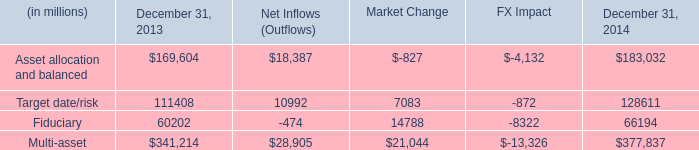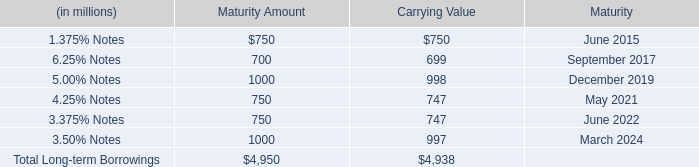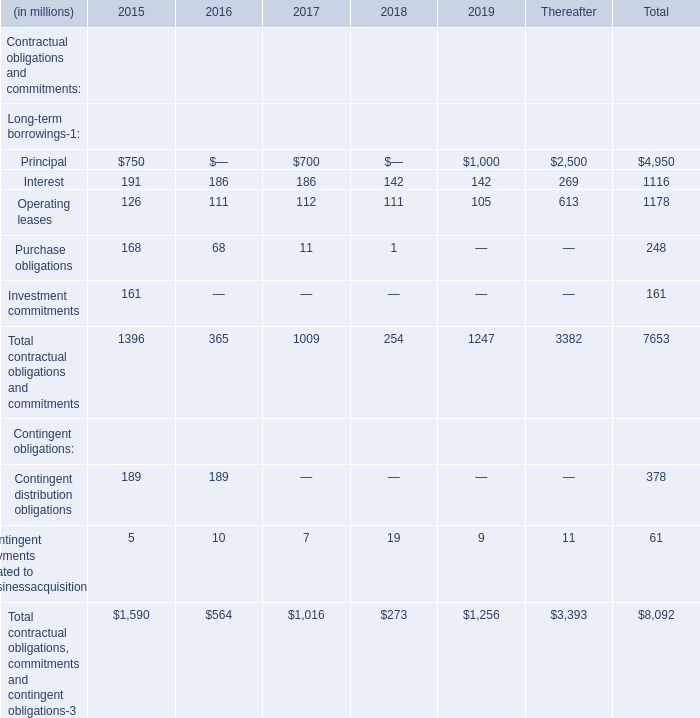What is the sum of 5.00% Notes for Carrying Value and Interest for Thereafter? (in million) 
Computations: (998 + 269)
Answer: 1267.0. 